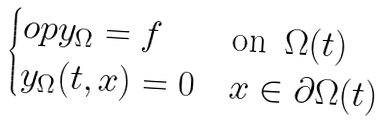Convert formula to latex. <formula><loc_0><loc_0><loc_500><loc_500>\begin{cases} \L o p y _ { \Omega } = f & \text {on } \, \Omega ( t ) \\ y _ { \Omega } ( t , x ) = 0 & x \in \partial \Omega ( t ) \end{cases}</formula> 